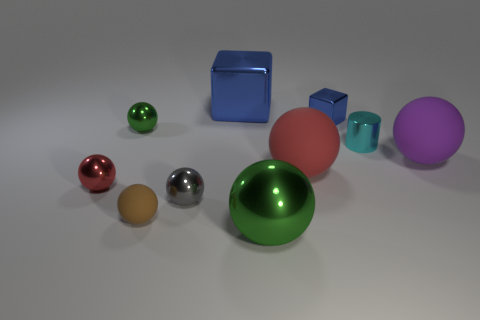Subtract 4 spheres. How many spheres are left? 3 Subtract all gray balls. How many balls are left? 6 Subtract all tiny shiny balls. How many balls are left? 4 Subtract all purple spheres. Subtract all gray blocks. How many spheres are left? 6 Subtract all cylinders. How many objects are left? 9 Add 2 large blue shiny things. How many large blue shiny things exist? 3 Subtract 0 brown cubes. How many objects are left? 10 Subtract all large green metallic cylinders. Subtract all small green spheres. How many objects are left? 9 Add 3 cylinders. How many cylinders are left? 4 